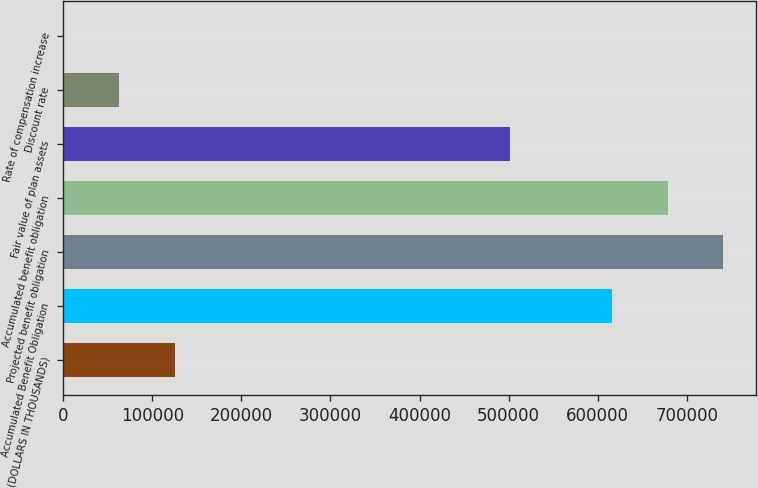Convert chart. <chart><loc_0><loc_0><loc_500><loc_500><bar_chart><fcel>(DOLLARS IN THOUSANDS)<fcel>Accumulated Benefit Obligation<fcel>Projected benefit obligation<fcel>Accumulated benefit obligation<fcel>Fair value of plan assets<fcel>Discount rate<fcel>Rate of compensation increase<nl><fcel>125098<fcel>616004<fcel>741099<fcel>678552<fcel>501801<fcel>62550.8<fcel>3.25<nl></chart> 